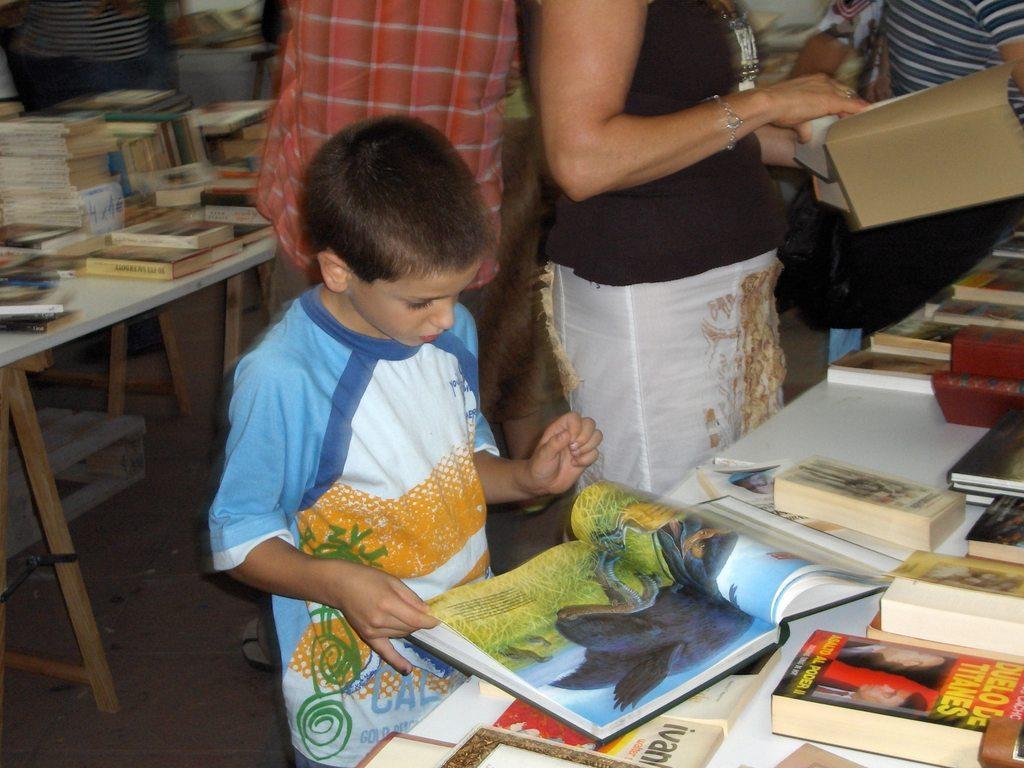Can you describe this image briefly? In this given picture, I can see couple of people holding books, Behind the people, I can see couple of books which is kept on table. 